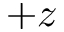Convert formula to latex. <formula><loc_0><loc_0><loc_500><loc_500>+ z</formula> 